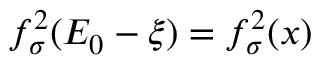<formula> <loc_0><loc_0><loc_500><loc_500>f _ { \sigma } ^ { 2 } ( E _ { 0 } - \xi ) = f _ { \sigma } ^ { 2 } ( x )</formula> 